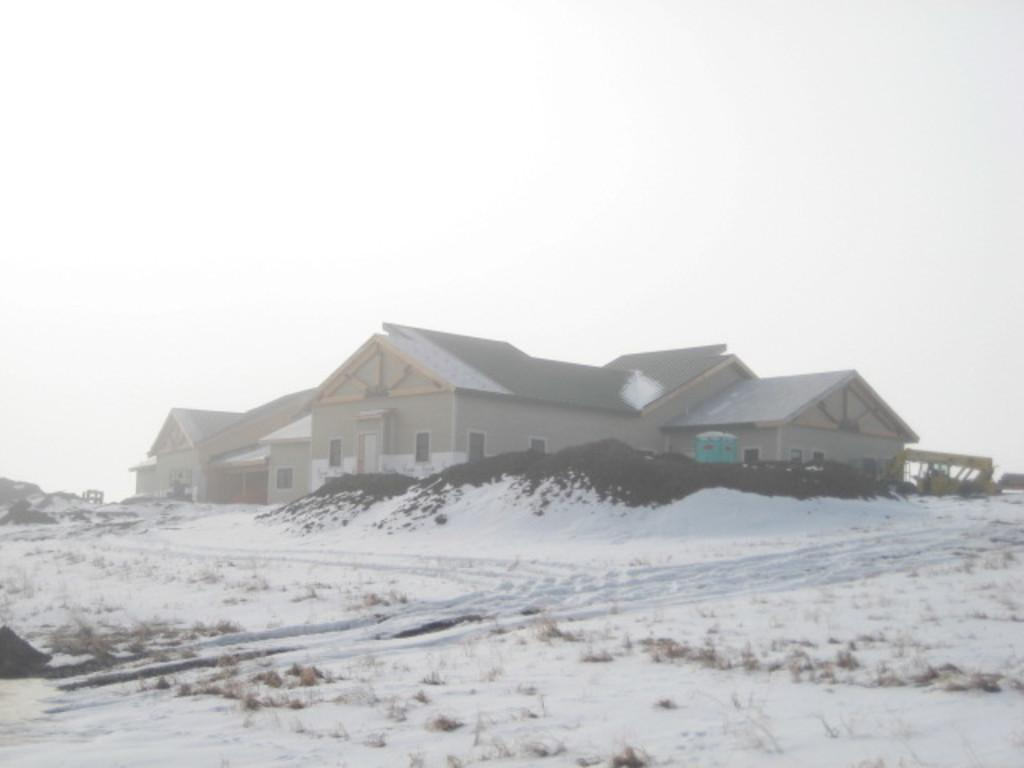What type of structures are present in the image? There are houses in the picture. What is the weather like in the image? There is snow visible in the picture, indicating a cold and likely wintery scene. What can be seen in the background of the image? The sky is visible in the background of the picture. What type of magic is being performed in the image? There is no indication of magic or any magical elements in the image; it simply features houses with snow and a visible sky. 